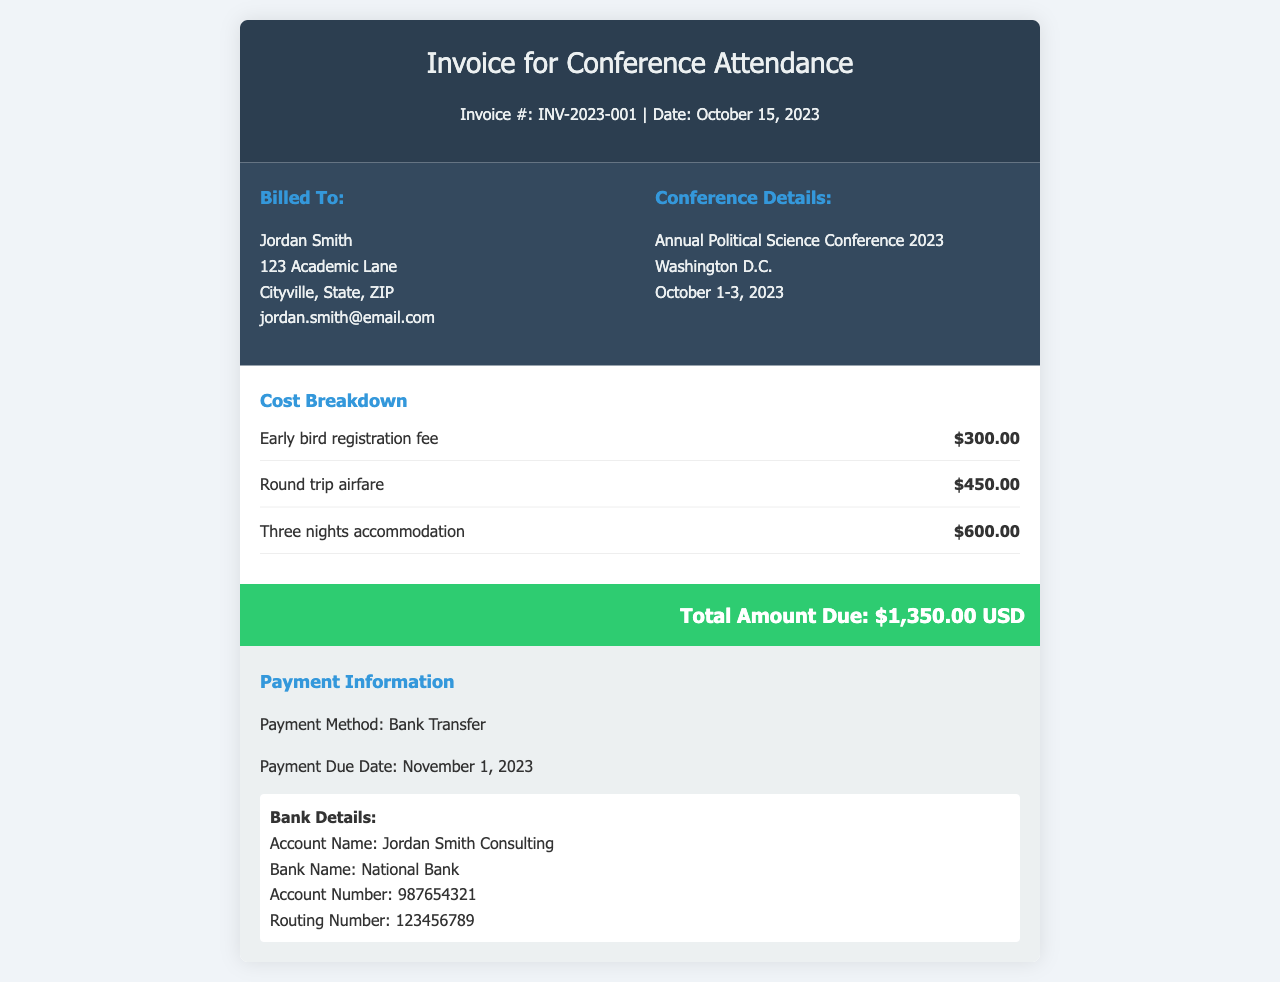What is the invoice number? The invoice number is listed directly under the title of the invoice.
Answer: INV-2023-001 What are the total travel expenses? Travel expenses consist of round trip airfare and three nights accommodation, totaling $450.00 + $600.00.
Answer: $1,050.00 Who is billed in this invoice? The billing information section contains the name and address of the individual or entity being billed.
Answer: Jordan Smith What is the early bird registration fee? The specific fee for early bird registration is provided in the cost breakdown.
Answer: $300.00 What is the payment due date? The payment due date is specified in the payment information section of the invoice.
Answer: November 1, 2023 How many nights of accommodation are included? The cost breakdown clearly states the duration of accommodation.
Answer: Three nights What is the total amount due? The total amount due is summarized at the bottom of the invoice.
Answer: $1,350.00 USD Where is the conference held? The conference details section includes the location of the event.
Answer: Washington D.C What is the payment method specified? The payment information section indicates how the payment should be made.
Answer: Bank Transfer 